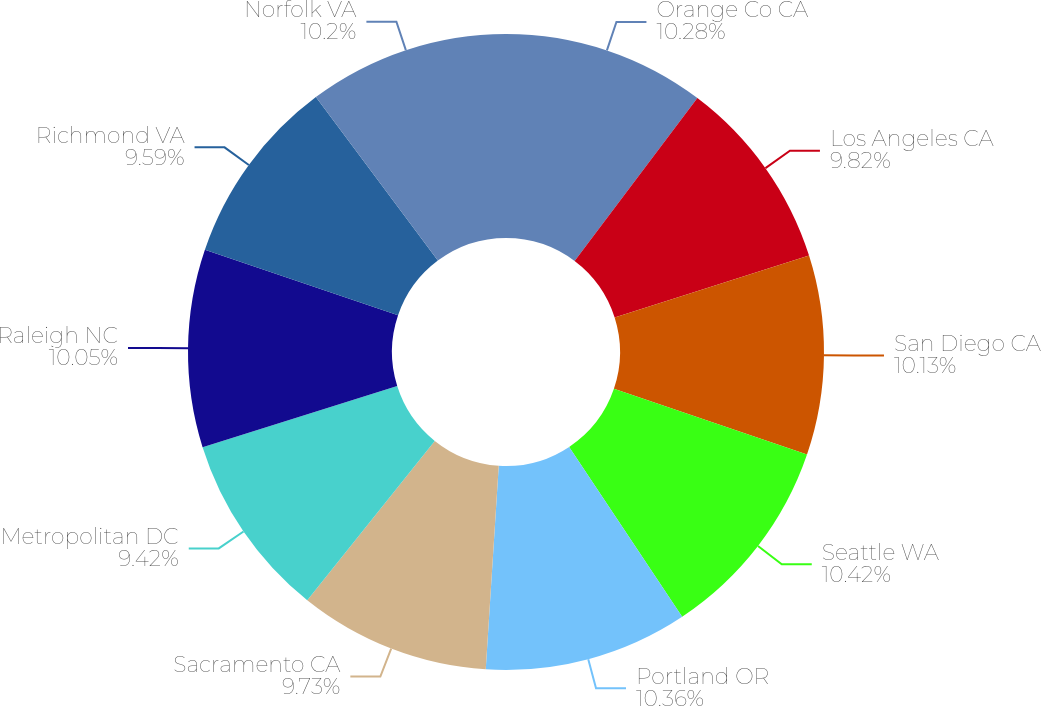<chart> <loc_0><loc_0><loc_500><loc_500><pie_chart><fcel>Orange Co CA<fcel>Los Angeles CA<fcel>San Diego CA<fcel>Seattle WA<fcel>Portland OR<fcel>Sacramento CA<fcel>Metropolitan DC<fcel>Raleigh NC<fcel>Richmond VA<fcel>Norfolk VA<nl><fcel>10.28%<fcel>9.82%<fcel>10.13%<fcel>10.43%<fcel>10.36%<fcel>9.73%<fcel>9.42%<fcel>10.05%<fcel>9.59%<fcel>10.2%<nl></chart> 